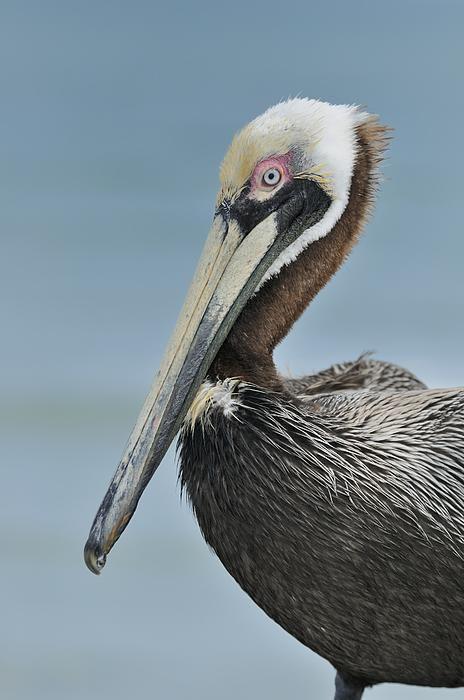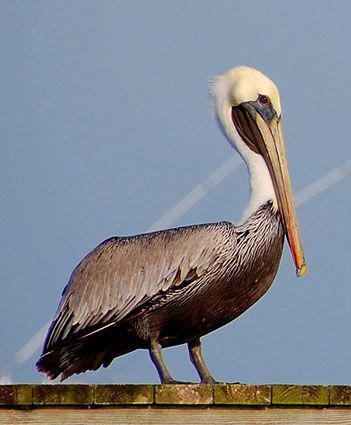The first image is the image on the left, the second image is the image on the right. Analyze the images presented: Is the assertion "A bird is sitting on water." valid? Answer yes or no. No. 